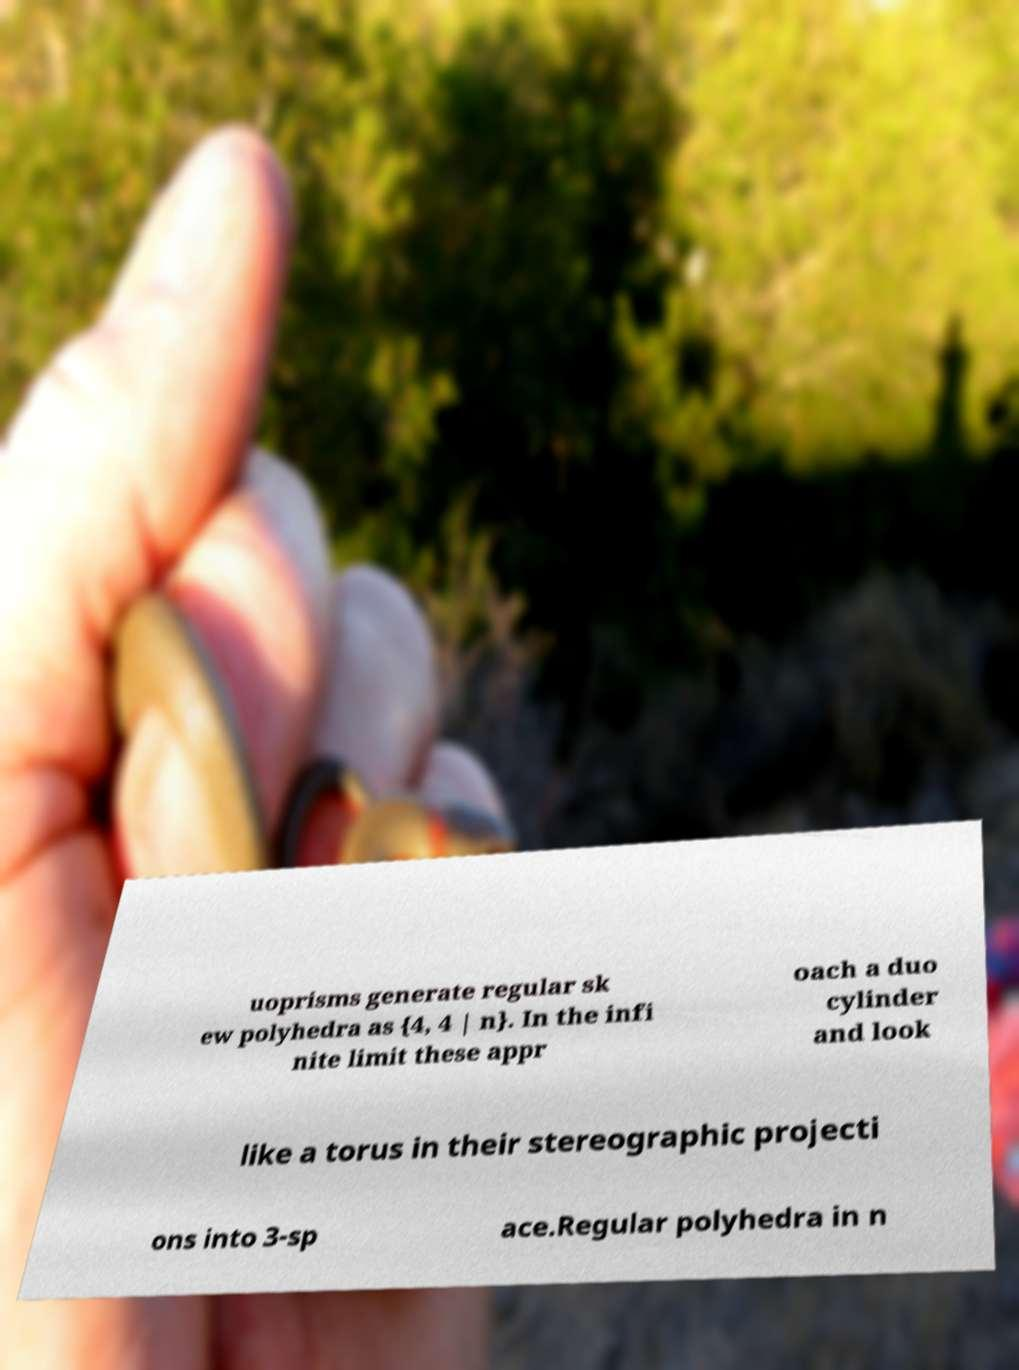Can you read and provide the text displayed in the image?This photo seems to have some interesting text. Can you extract and type it out for me? uoprisms generate regular sk ew polyhedra as {4, 4 | n}. In the infi nite limit these appr oach a duo cylinder and look like a torus in their stereographic projecti ons into 3-sp ace.Regular polyhedra in n 